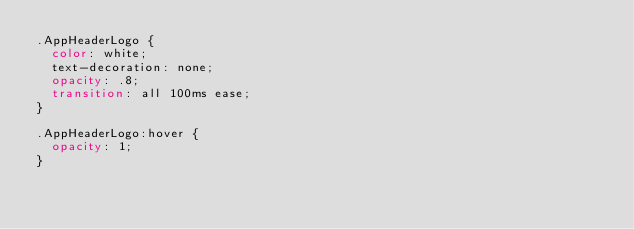Convert code to text. <code><loc_0><loc_0><loc_500><loc_500><_CSS_>.AppHeaderLogo {
  color: white;
  text-decoration: none;
  opacity: .8;
  transition: all 100ms ease;
}

.AppHeaderLogo:hover {
  opacity: 1;
}
</code> 